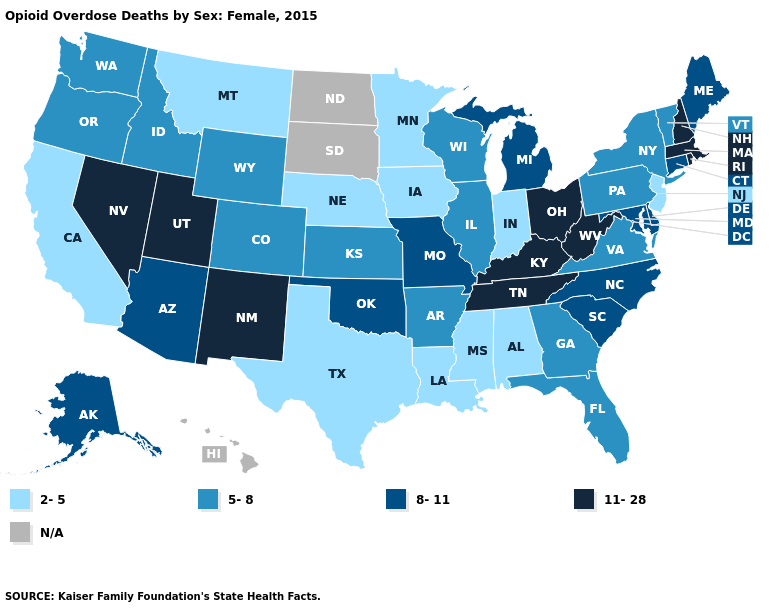Does the map have missing data?
Answer briefly. Yes. Name the states that have a value in the range 5-8?
Quick response, please. Arkansas, Colorado, Florida, Georgia, Idaho, Illinois, Kansas, New York, Oregon, Pennsylvania, Vermont, Virginia, Washington, Wisconsin, Wyoming. What is the highest value in states that border Kentucky?
Write a very short answer. 11-28. What is the value of Washington?
Concise answer only. 5-8. Does the first symbol in the legend represent the smallest category?
Answer briefly. Yes. What is the value of New Jersey?
Give a very brief answer. 2-5. Name the states that have a value in the range 2-5?
Give a very brief answer. Alabama, California, Indiana, Iowa, Louisiana, Minnesota, Mississippi, Montana, Nebraska, New Jersey, Texas. What is the value of West Virginia?
Be succinct. 11-28. Name the states that have a value in the range 5-8?
Give a very brief answer. Arkansas, Colorado, Florida, Georgia, Idaho, Illinois, Kansas, New York, Oregon, Pennsylvania, Vermont, Virginia, Washington, Wisconsin, Wyoming. Does New Jersey have the lowest value in the USA?
Concise answer only. Yes. What is the value of Ohio?
Be succinct. 11-28. Among the states that border Kansas , does Missouri have the highest value?
Keep it brief. Yes. What is the lowest value in the USA?
Write a very short answer. 2-5. Does Kentucky have the highest value in the South?
Be succinct. Yes. 